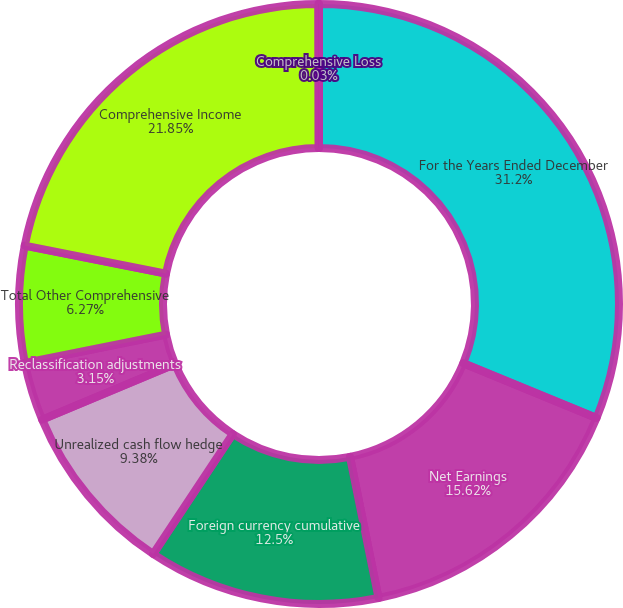Convert chart to OTSL. <chart><loc_0><loc_0><loc_500><loc_500><pie_chart><fcel>For the Years Ended December<fcel>Net Earnings<fcel>Foreign currency cumulative<fcel>Unrealized cash flow hedge<fcel>Reclassification adjustments<fcel>Total Other Comprehensive<fcel>Comprehensive Income<fcel>Comprehensive Loss<nl><fcel>31.2%<fcel>15.62%<fcel>12.5%<fcel>9.38%<fcel>3.15%<fcel>6.27%<fcel>21.85%<fcel>0.03%<nl></chart> 